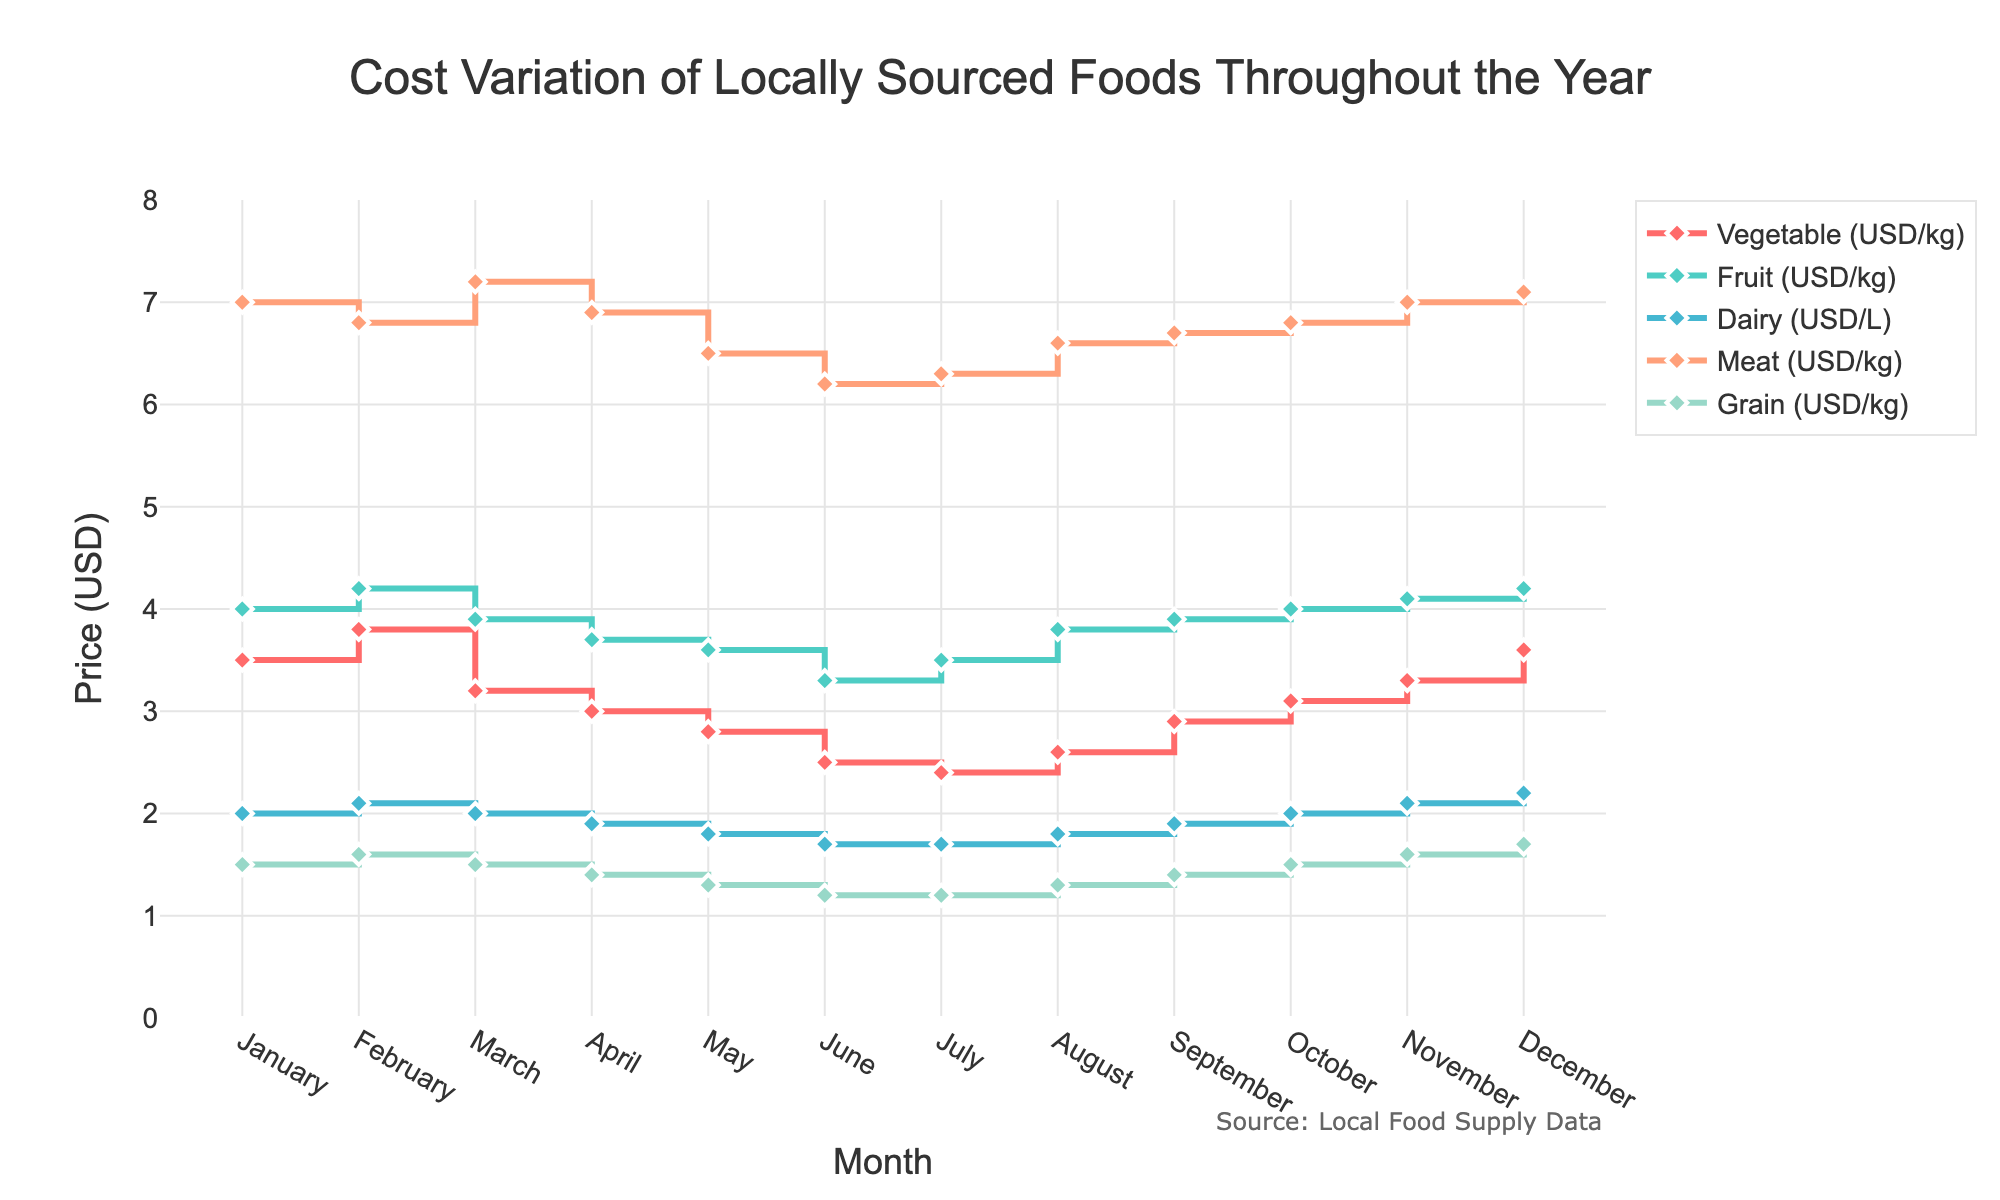What is the title of the plot? The title is located at the top center of the plot and is clearly visible.
Answer: Cost Variation of Locally Sourced Foods Throughout the Year Which month shows the highest price for vegetables? Look for the point on the vegetable line (red) that reaches the highest value on the y-axis.
Answer: February In which month does meat have the lowest cost? Look for the lowest point on the meat line (orange).
Answer: June What is the price difference between vegetables and fruits in May? Identify the prices for vegetables and fruits in May and subtract the value of vegetables from fruits. 3.6 - 2.8 = 0.8
Answer: 0.8 USD Which food category shows the smallest price change throughout the year? Compare the ranges (maximum - minimum) of prices for all food categories; the category with the smallest range shows the least variation.
Answer: Grain What's the average cost of dairy in July and August? Identify the prices for dairy in July and August, then sum them up and divide by 2. (1.7 + 1.8) / 2 = 1.75
Answer: 1.75 USD Which food category has the highest price in December? Look for the data points in December and identify the category with the highest price.
Answer: Meat During which month is the cost of grain equal to the cost of meat in January? Identify the cost of meat in January (7.0) and find the month where the cost of grain matches it. No month matches this condition.
Answer: No month What is the overall price trend for fruits from January to December? Observe the fruit prices month by month; identify if they generally increase, decrease, or fluctuate.
Answer: Increase In which two consecutive months does the cost of grains change the most? Calculate the month-to-month difference in grain prices, and identify the two months with the largest difference. May to June (1.3 - 1.2 = 0.1) and September to October (1.5 - 1.6 = -0.1). Both changes are equivalent and largest.
Answer: May to June / September to October 